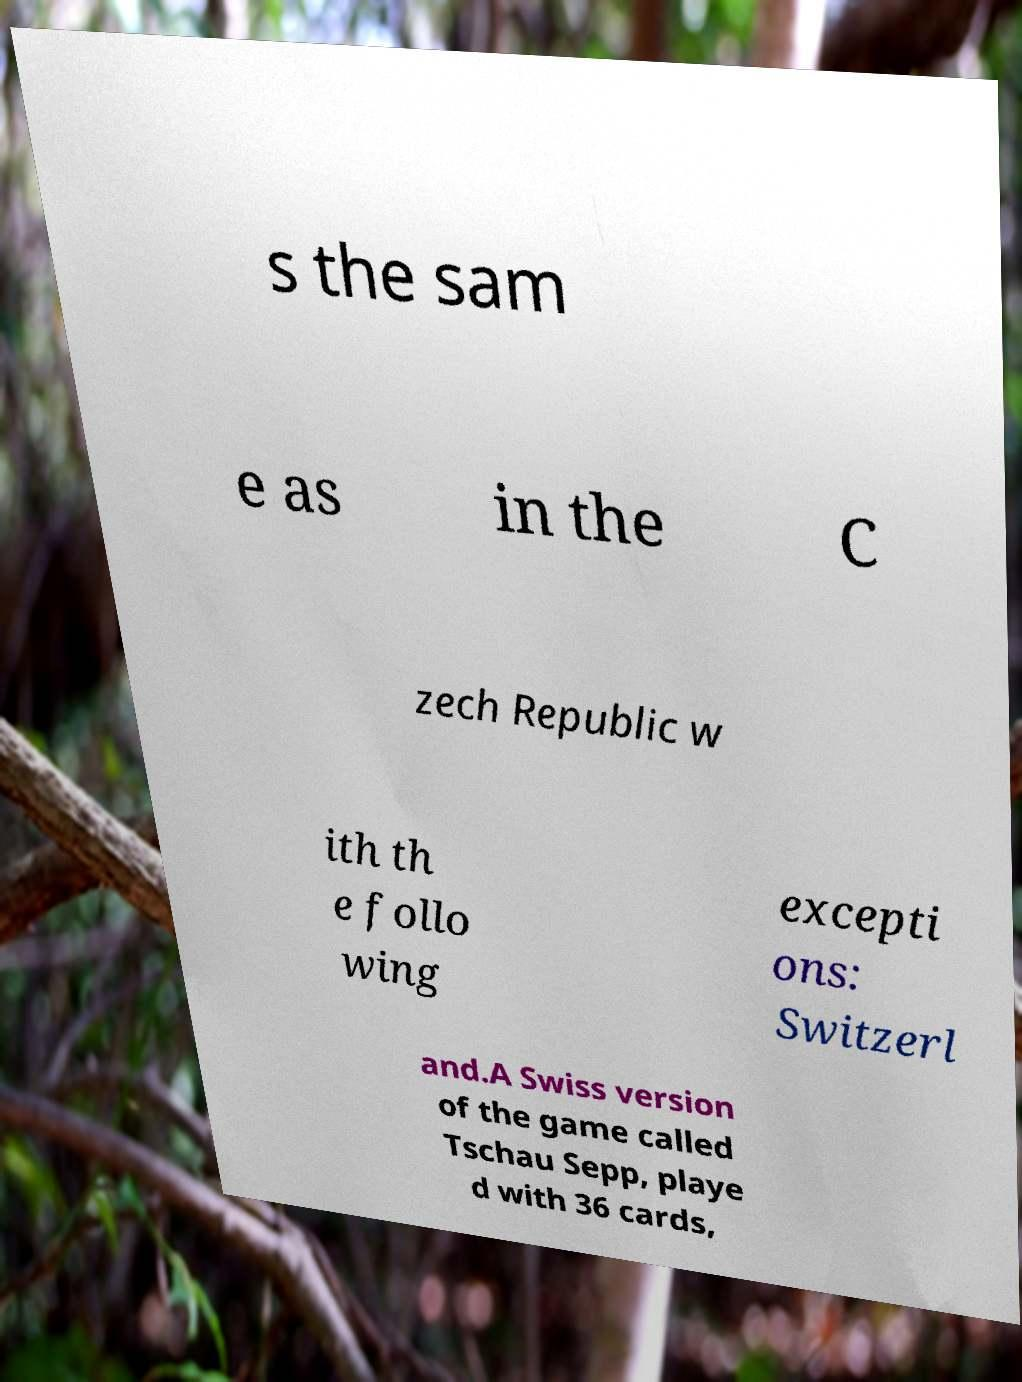Please identify and transcribe the text found in this image. s the sam e as in the C zech Republic w ith th e follo wing excepti ons: Switzerl and.A Swiss version of the game called Tschau Sepp, playe d with 36 cards, 